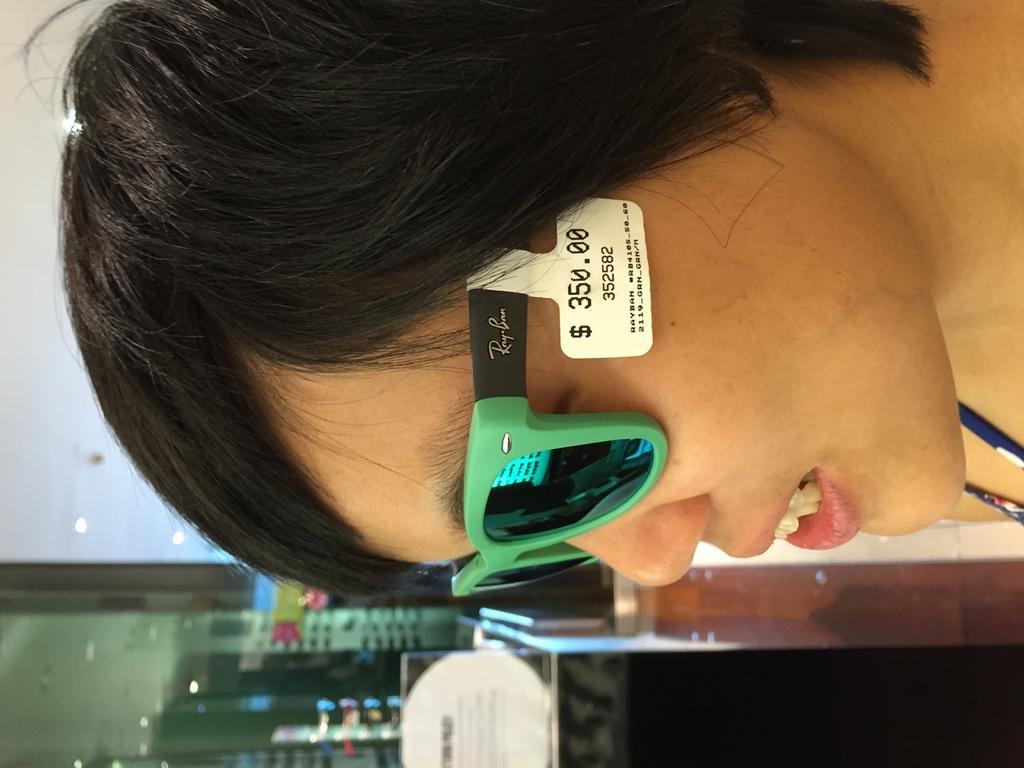Describe this image in one or two sentences. In this image, we can see a person wearing glasses with a tag and in the background, there are stands, glass door, lights, a board and some objects and a wall. 